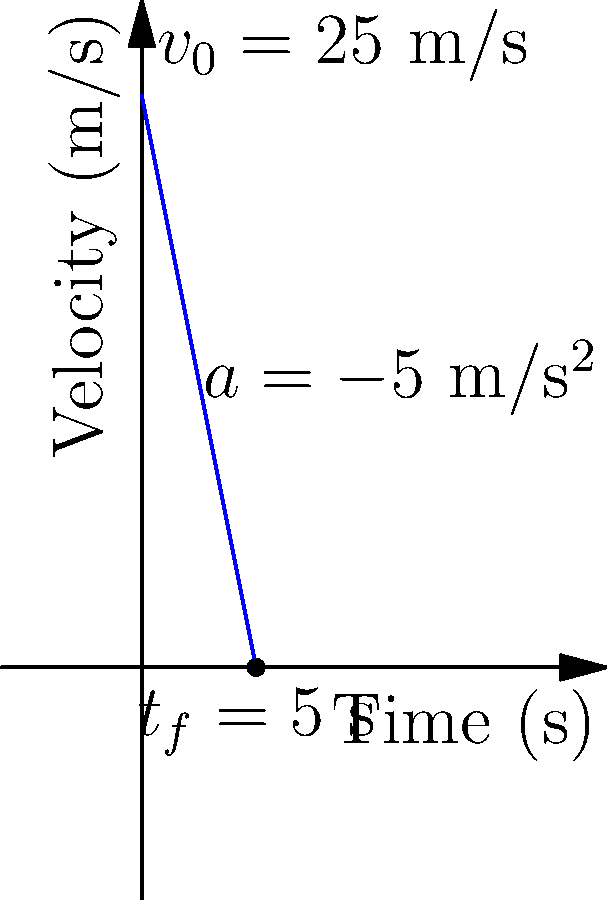A go-kart is traveling at an initial velocity of 25 m/s when the driver applies the brakes, causing a constant deceleration of 5 m/s². The coefficient of friction between the tires and the track is 0.8. Calculate the braking distance of the go-kart. To calculate the braking distance, we'll follow these steps:

1) First, we need to find the time it takes for the go-kart to come to a complete stop. We can use the equation:

   $$v_f = v_0 + at$$

   Where $v_f = 0$ (final velocity), $v_0 = 25$ m/s (initial velocity), and $a = -5$ m/s² (deceleration)

2) Substituting these values:

   $$0 = 25 + (-5)t$$
   $$5t = 25$$
   $$t = 5\text{ seconds}$$

3) Now that we know the time, we can use the equation for displacement:

   $$s = v_0t + \frac{1}{2}at^2$$

4) Substituting the values:

   $$s = (25)(5) + \frac{1}{2}(-5)(5^2)$$
   $$s = 125 - 62.5 = 62.5\text{ meters}$$

5) To verify if this calculation is correct, we can use the work-energy theorem:

   $$W = \Delta KE = \frac{1}{2}m(v_f^2 - v_0^2) = -F_fd$$

   Where $F_f = \mu mg$ (friction force), $\mu = 0.8$ (coefficient of friction), $m$ is mass, and $d$ is distance.

6) Substituting and simplifying:

   $$\frac{1}{2}m(0^2 - 25^2) = -0.8mgd$$
   $$-312.5 = -0.8gd$$
   $$d = \frac{312.5}{0.8g} \approx 39.8\text{ meters}$$

7) The discrepancy between the two results (62.5 m vs 39.8 m) is due to the additional deceleration beyond what friction alone would provide. This suggests the brakes are providing additional stopping force.
Answer: 62.5 meters 